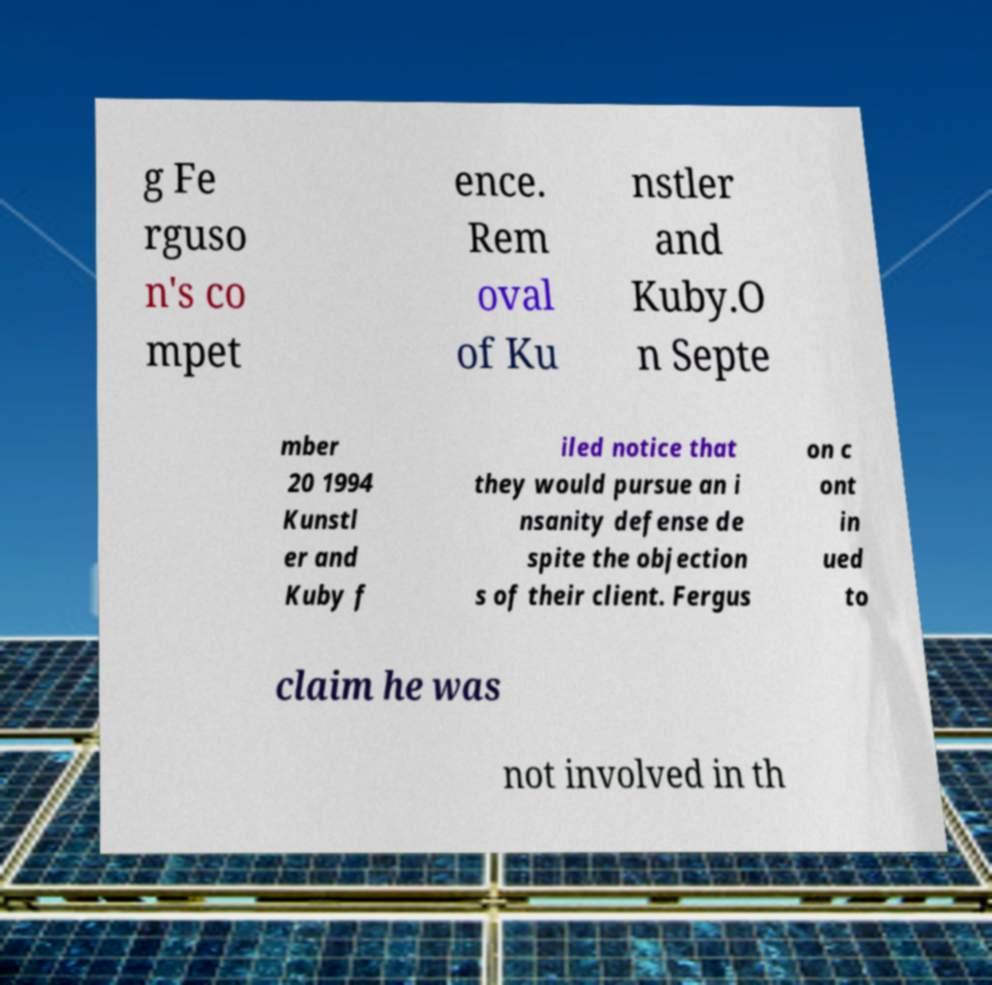Could you extract and type out the text from this image? g Fe rguso n's co mpet ence. Rem oval of Ku nstler and Kuby.O n Septe mber 20 1994 Kunstl er and Kuby f iled notice that they would pursue an i nsanity defense de spite the objection s of their client. Fergus on c ont in ued to claim he was not involved in th 